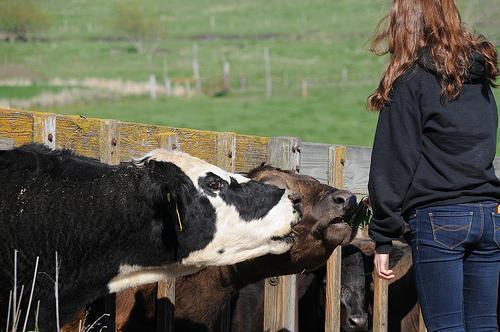How many girls are in the photo?
Give a very brief answer. 1. How many pairs of jeans are in the photo?
Give a very brief answer. 1. How many jackets are in the photo?
Give a very brief answer. 1. How many girls in brown hair are in the photo?
Give a very brief answer. 1. How many cows?
Give a very brief answer. 2. 